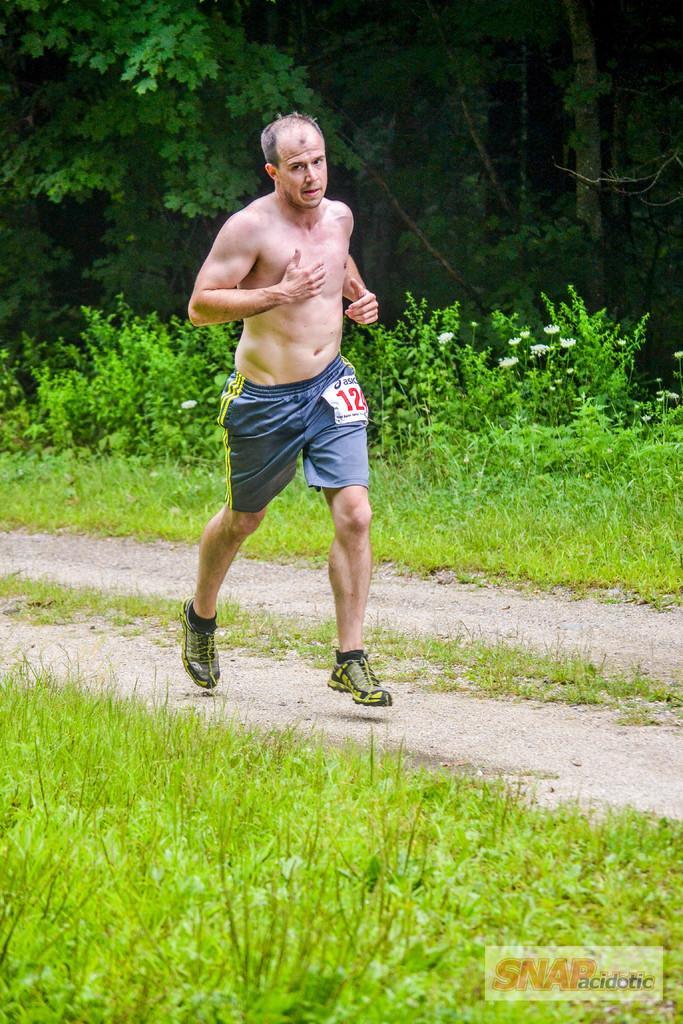Could you give a brief overview of what you see in this image? In this image we can see a person wearing blue color short, black color shoes running and in the background of the image there are some trees and grass. 